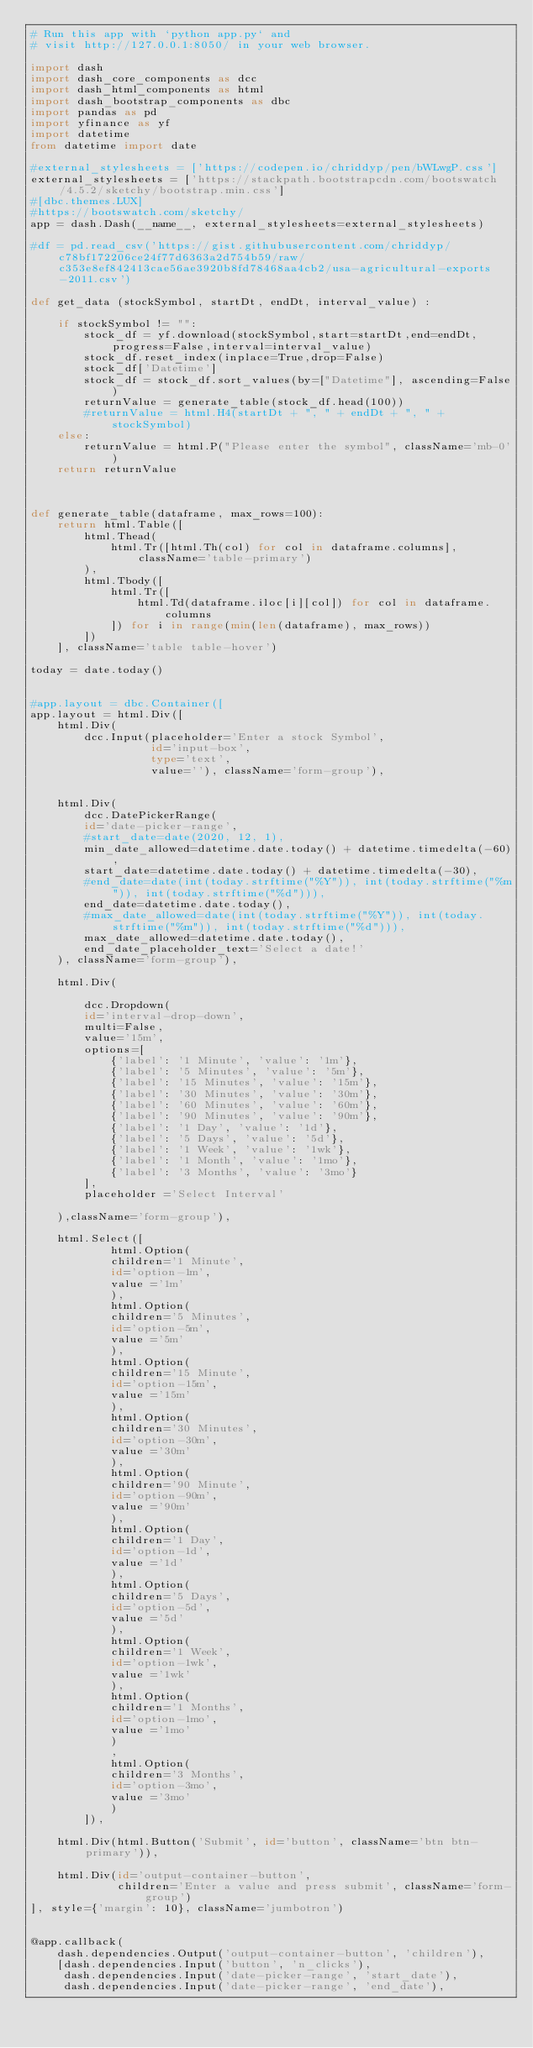<code> <loc_0><loc_0><loc_500><loc_500><_Python_># Run this app with `python app.py` and
# visit http://127.0.0.1:8050/ in your web browser.

import dash
import dash_core_components as dcc
import dash_html_components as html
import dash_bootstrap_components as dbc
import pandas as pd
import yfinance as yf
import datetime
from datetime import date

#external_stylesheets = ['https://codepen.io/chriddyp/pen/bWLwgP.css']
external_stylesheets = ['https://stackpath.bootstrapcdn.com/bootswatch/4.5.2/sketchy/bootstrap.min.css']
#[dbc.themes.LUX]
#https://bootswatch.com/sketchy/
app = dash.Dash(__name__, external_stylesheets=external_stylesheets)

#df = pd.read_csv('https://gist.githubusercontent.com/chriddyp/c78bf172206ce24f77d6363a2d754b59/raw/c353e8ef842413cae56ae3920b8fd78468aa4cb2/usa-agricultural-exports-2011.csv')

def get_data (stockSymbol, startDt, endDt, interval_value) :
    
    if stockSymbol != "":
        stock_df = yf.download(stockSymbol,start=startDt,end=endDt,progress=False,interval=interval_value)
        stock_df.reset_index(inplace=True,drop=False)
        stock_df['Datetime'] 
        stock_df = stock_df.sort_values(by=["Datetime"], ascending=False)
        returnValue = generate_table(stock_df.head(100))
        #returnValue = html.H4(startDt + ", " + endDt + ", " + stockSymbol)
    else:
        returnValue = html.P("Please enter the symbol", className='mb-0')
    return returnValue
    
    

def generate_table(dataframe, max_rows=100):
    return html.Table([
        html.Thead(
            html.Tr([html.Th(col) for col in dataframe.columns], className='table-primary')
        ),
        html.Tbody([
            html.Tr([
                html.Td(dataframe.iloc[i][col]) for col in dataframe.columns
            ]) for i in range(min(len(dataframe), max_rows))
        ])
    ], className='table table-hover')

today = date.today()


#app.layout = dbc.Container([ 
app.layout = html.Div([   
    html.Div(
        dcc.Input(placeholder='Enter a stock Symbol',
                  id='input-box',
                  type='text',
                  value=''), className='form-group'),


    html.Div(
        dcc.DatePickerRange(
        id='date-picker-range',
        #start_date=date(2020, 12, 1),
        min_date_allowed=datetime.date.today() + datetime.timedelta(-60),
        start_date=datetime.date.today() + datetime.timedelta(-30),
        #end_date=date(int(today.strftime("%Y")), int(today.strftime("%m")), int(today.strftime("%d"))),
        end_date=datetime.date.today(),
        #max_date_allowed=date(int(today.strftime("%Y")), int(today.strftime("%m")), int(today.strftime("%d"))),
        max_date_allowed=datetime.date.today(),
        end_date_placeholder_text='Select a date!'
    ), className='form-group'),

    html.Div(
        
        dcc.Dropdown(
        id='interval-drop-down',
        multi=False,
        value='15m',
        options=[
            {'label': '1 Minute', 'value': '1m'},
            {'label': '5 Minutes', 'value': '5m'},
            {'label': '15 Minutes', 'value': '15m'},
            {'label': '30 Minutes', 'value': '30m'},
            {'label': '60 Minutes', 'value': '60m'},
            {'label': '90 Minutes', 'value': '90m'},
            {'label': '1 Day', 'value': '1d'},
            {'label': '5 Days', 'value': '5d'},
            {'label': '1 Week', 'value': '1wk'},
            {'label': '1 Month', 'value': '1mo'},
            {'label': '3 Months', 'value': '3mo'}
        ],
        placeholder ='Select Interval'
        
    ),className='form-group'),

    html.Select([
            html.Option(
            children='1 Minute',
            id='option-1m',
            value ='1m'
            ),
            html.Option(
            children='5 Minutes',
            id='option-5m',
            value ='5m'
            ),
            html.Option(
            children='15 Minute',
            id='option-15m',
            value ='15m'
            ),
            html.Option(
            children='30 Minutes',
            id='option-30m',
            value ='30m'
            ),
            html.Option(
            children='90 Minute',
            id='option-90m',
            value ='90m'
            ),
            html.Option(
            children='1 Day',
            id='option-1d',
            value ='1d'
            ),
            html.Option(
            children='5 Days',
            id='option-5d',
            value ='5d'
            ),
            html.Option(
            children='1 Week',
            id='option-1wk',
            value ='1wk'
            ),
            html.Option(
            children='1 Months',
            id='option-1mo',
            value ='1mo'
            )
            ,
            html.Option(
            children='3 Months',
            id='option-3mo',
            value ='3mo'
            )
        ]),
    
    html.Div(html.Button('Submit', id='button', className='btn btn-primary')),

    html.Div(id='output-container-button',
             children='Enter a value and press submit', className='form-group')
], style={'margin': 10}, className='jumbotron')


@app.callback(
    dash.dependencies.Output('output-container-button', 'children'),
    [dash.dependencies.Input('button', 'n_clicks'),
     dash.dependencies.Input('date-picker-range', 'start_date'),
     dash.dependencies.Input('date-picker-range', 'end_date'),</code> 